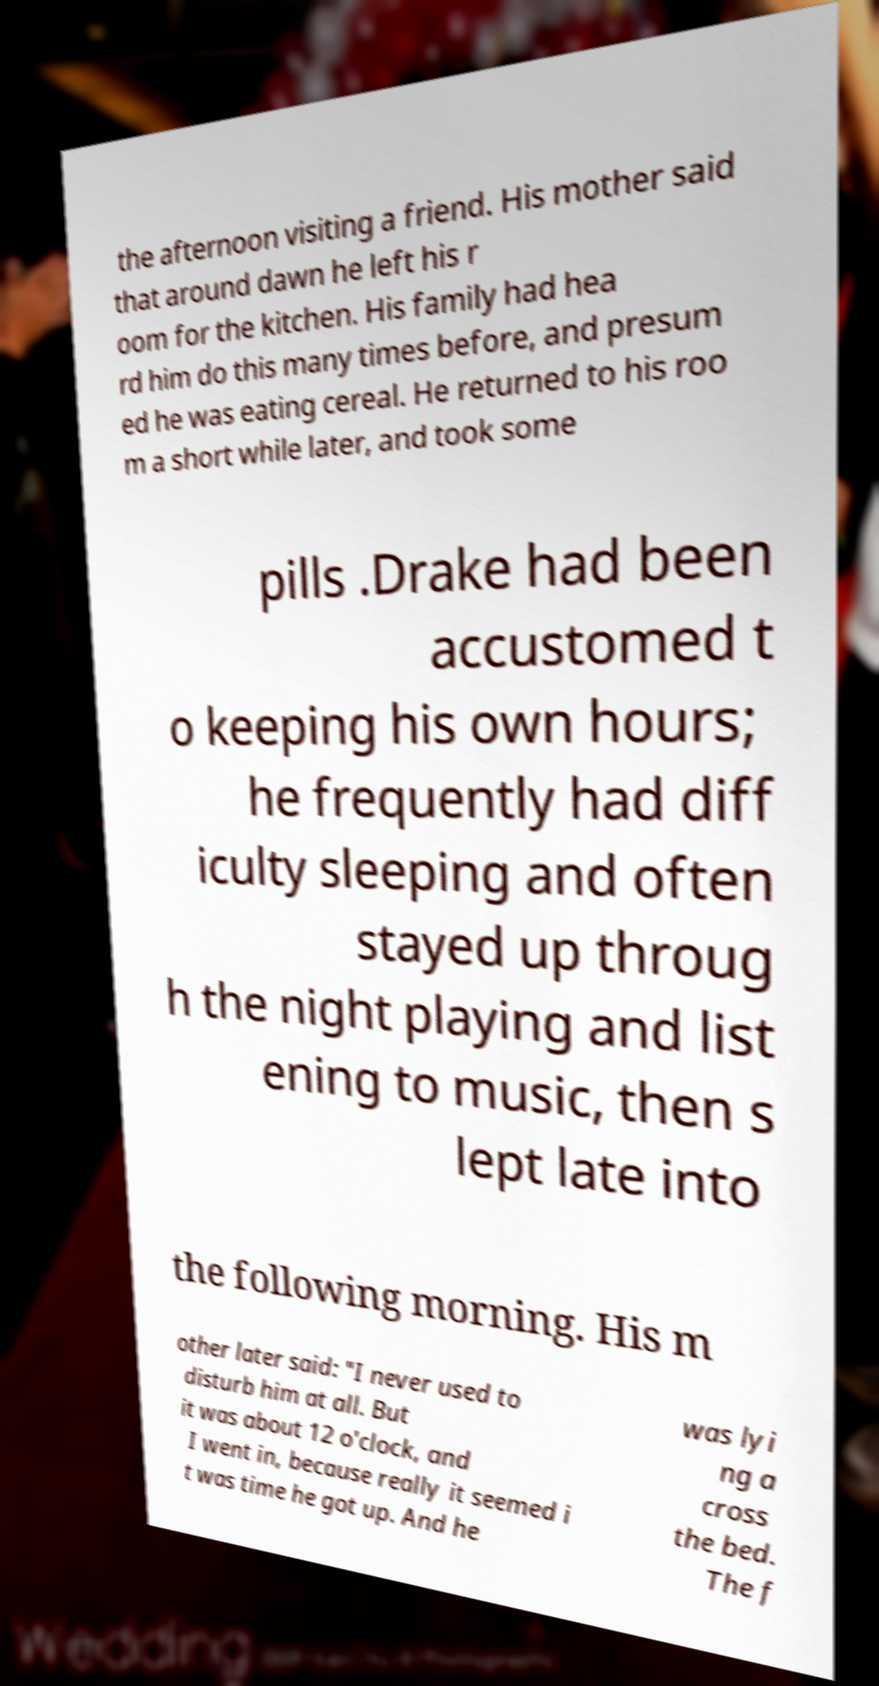I need the written content from this picture converted into text. Can you do that? the afternoon visiting a friend. His mother said that around dawn he left his r oom for the kitchen. His family had hea rd him do this many times before, and presum ed he was eating cereal. He returned to his roo m a short while later, and took some pills .Drake had been accustomed t o keeping his own hours; he frequently had diff iculty sleeping and often stayed up throug h the night playing and list ening to music, then s lept late into the following morning. His m other later said: "I never used to disturb him at all. But it was about 12 o'clock, and I went in, because really it seemed i t was time he got up. And he was lyi ng a cross the bed. The f 